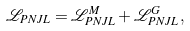Convert formula to latex. <formula><loc_0><loc_0><loc_500><loc_500>\mathcal { L } _ { P N J L } = \mathcal { L } _ { P N J L } ^ { M } + \mathcal { L } _ { P N J L } ^ { G } \, ,</formula> 